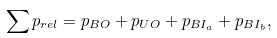<formula> <loc_0><loc_0><loc_500><loc_500>\sum p _ { r e l } = p _ { B O } + p _ { U O } + p _ { B I _ { a } } + p _ { B I _ { b } } ,</formula> 